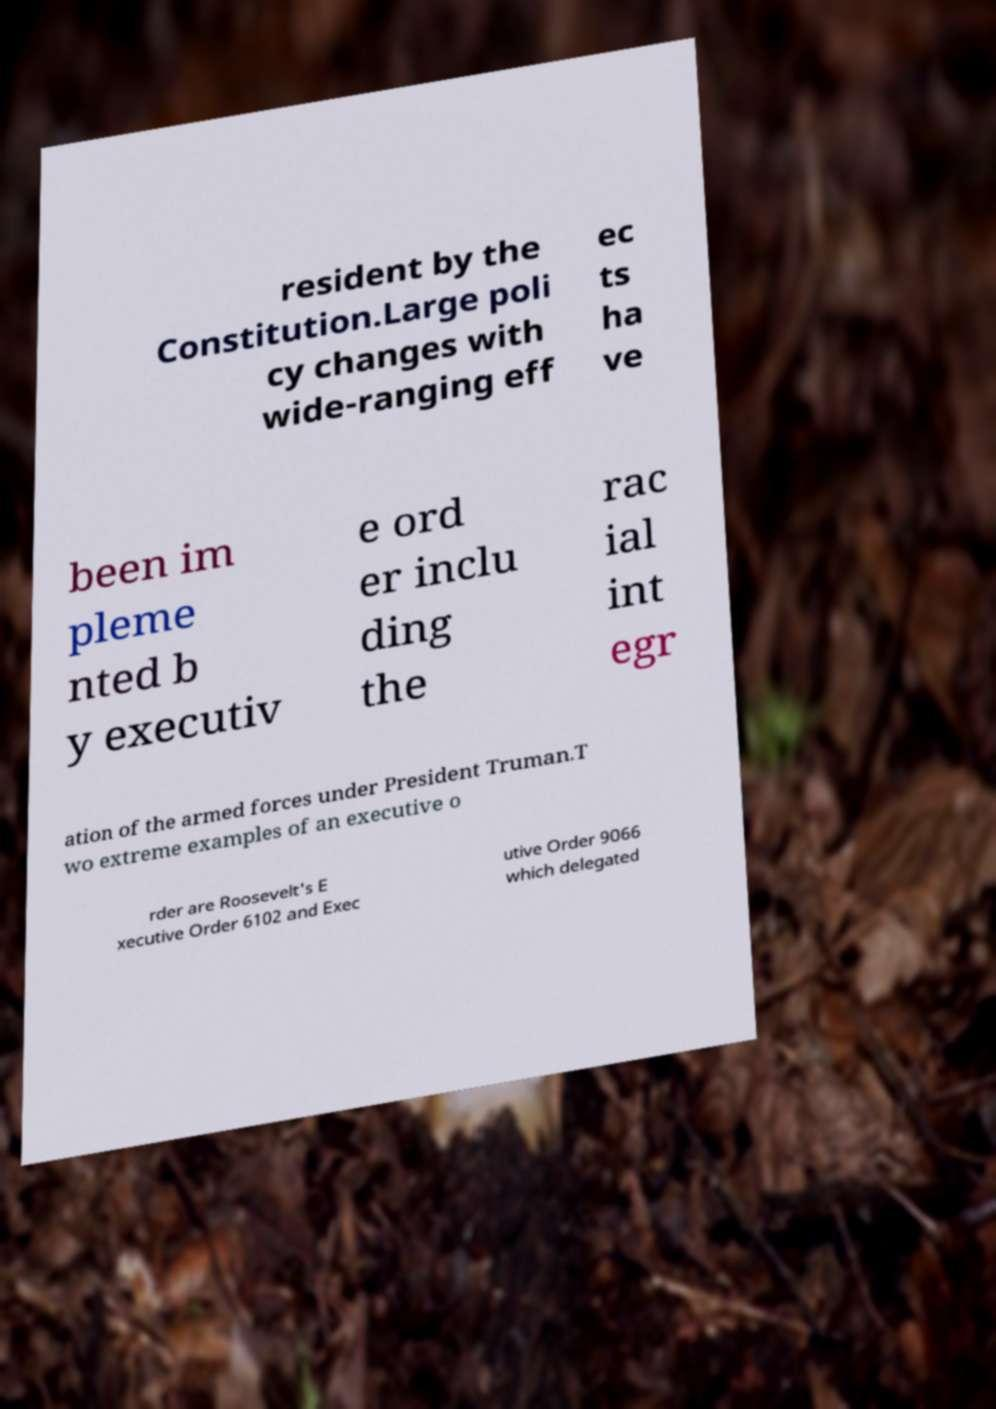For documentation purposes, I need the text within this image transcribed. Could you provide that? resident by the Constitution.Large poli cy changes with wide-ranging eff ec ts ha ve been im pleme nted b y executiv e ord er inclu ding the rac ial int egr ation of the armed forces under President Truman.T wo extreme examples of an executive o rder are Roosevelt's E xecutive Order 6102 and Exec utive Order 9066 which delegated 